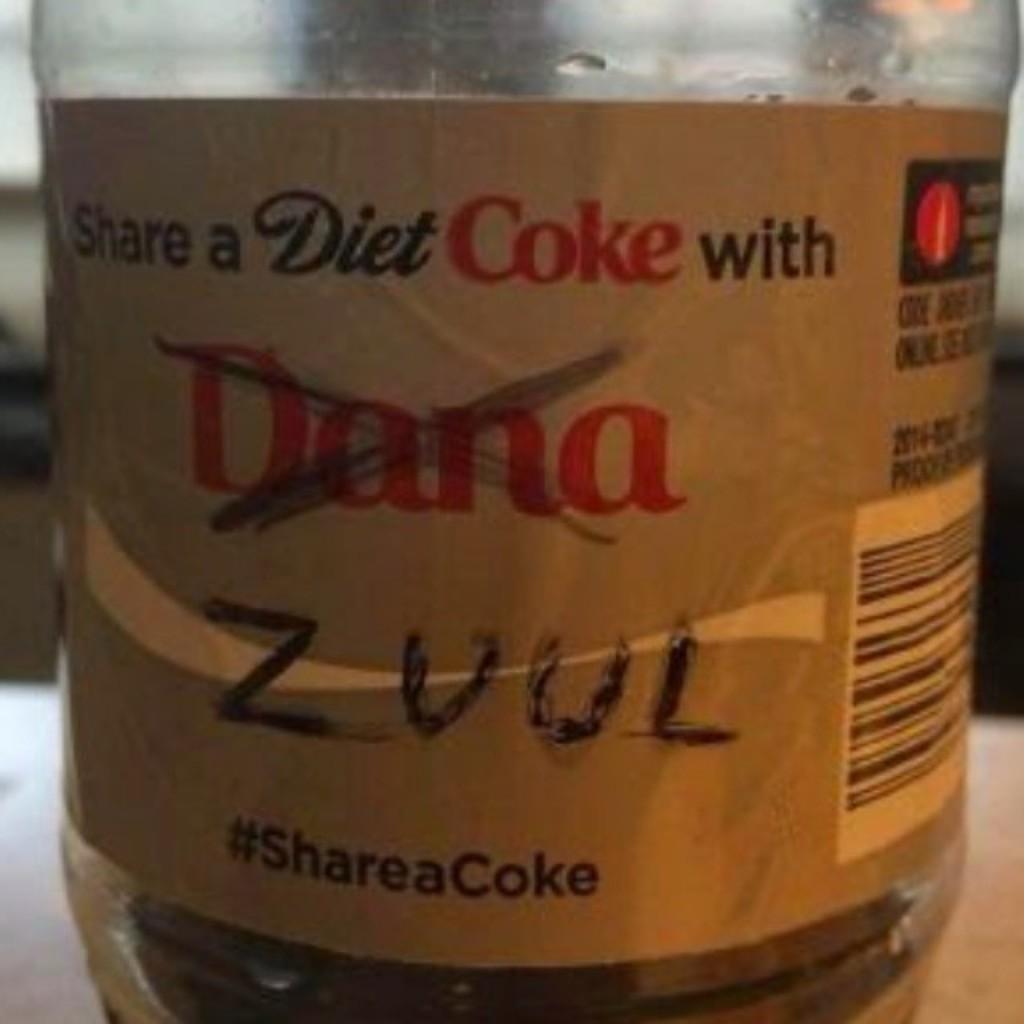What kind of coke is that?
Make the answer very short. Diet. What sis the name that is scratched out?
Provide a short and direct response. Dana. 